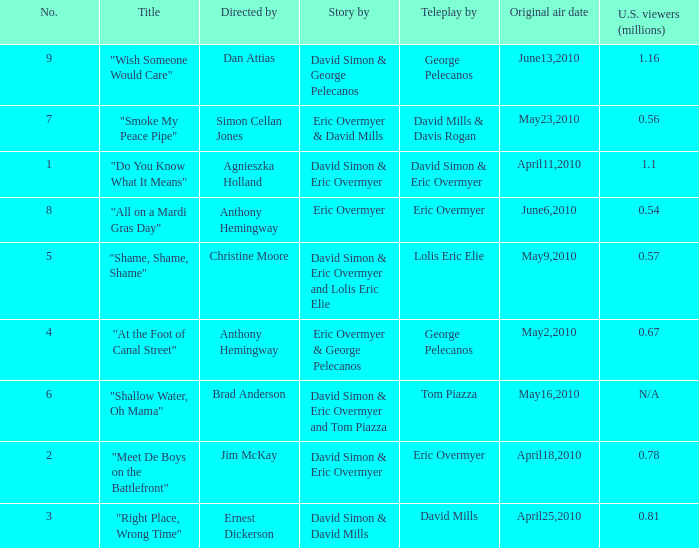Name the teleplay for  david simon & eric overmyer and tom piazza Tom Piazza. Could you help me parse every detail presented in this table? {'header': ['No.', 'Title', 'Directed by', 'Story by', 'Teleplay by', 'Original air date', 'U.S. viewers (millions)'], 'rows': [['9', '"Wish Someone Would Care"', 'Dan Attias', 'David Simon & George Pelecanos', 'George Pelecanos', 'June13,2010', '1.16'], ['7', '"Smoke My Peace Pipe"', 'Simon Cellan Jones', 'Eric Overmyer & David Mills', 'David Mills & Davis Rogan', 'May23,2010', '0.56'], ['1', '"Do You Know What It Means"', 'Agnieszka Holland', 'David Simon & Eric Overmyer', 'David Simon & Eric Overmyer', 'April11,2010', '1.1'], ['8', '"All on a Mardi Gras Day"', 'Anthony Hemingway', 'Eric Overmyer', 'Eric Overmyer', 'June6,2010', '0.54'], ['5', '"Shame, Shame, Shame"', 'Christine Moore', 'David Simon & Eric Overmyer and Lolis Eric Elie', 'Lolis Eric Elie', 'May9,2010', '0.57'], ['4', '"At the Foot of Canal Street"', 'Anthony Hemingway', 'Eric Overmyer & George Pelecanos', 'George Pelecanos', 'May2,2010', '0.67'], ['6', '"Shallow Water, Oh Mama"', 'Brad Anderson', 'David Simon & Eric Overmyer and Tom Piazza', 'Tom Piazza', 'May16,2010', 'N/A'], ['2', '"Meet De Boys on the Battlefront"', 'Jim McKay', 'David Simon & Eric Overmyer', 'Eric Overmyer', 'April18,2010', '0.78'], ['3', '"Right Place, Wrong Time"', 'Ernest Dickerson', 'David Simon & David Mills', 'David Mills', 'April25,2010', '0.81']]} 